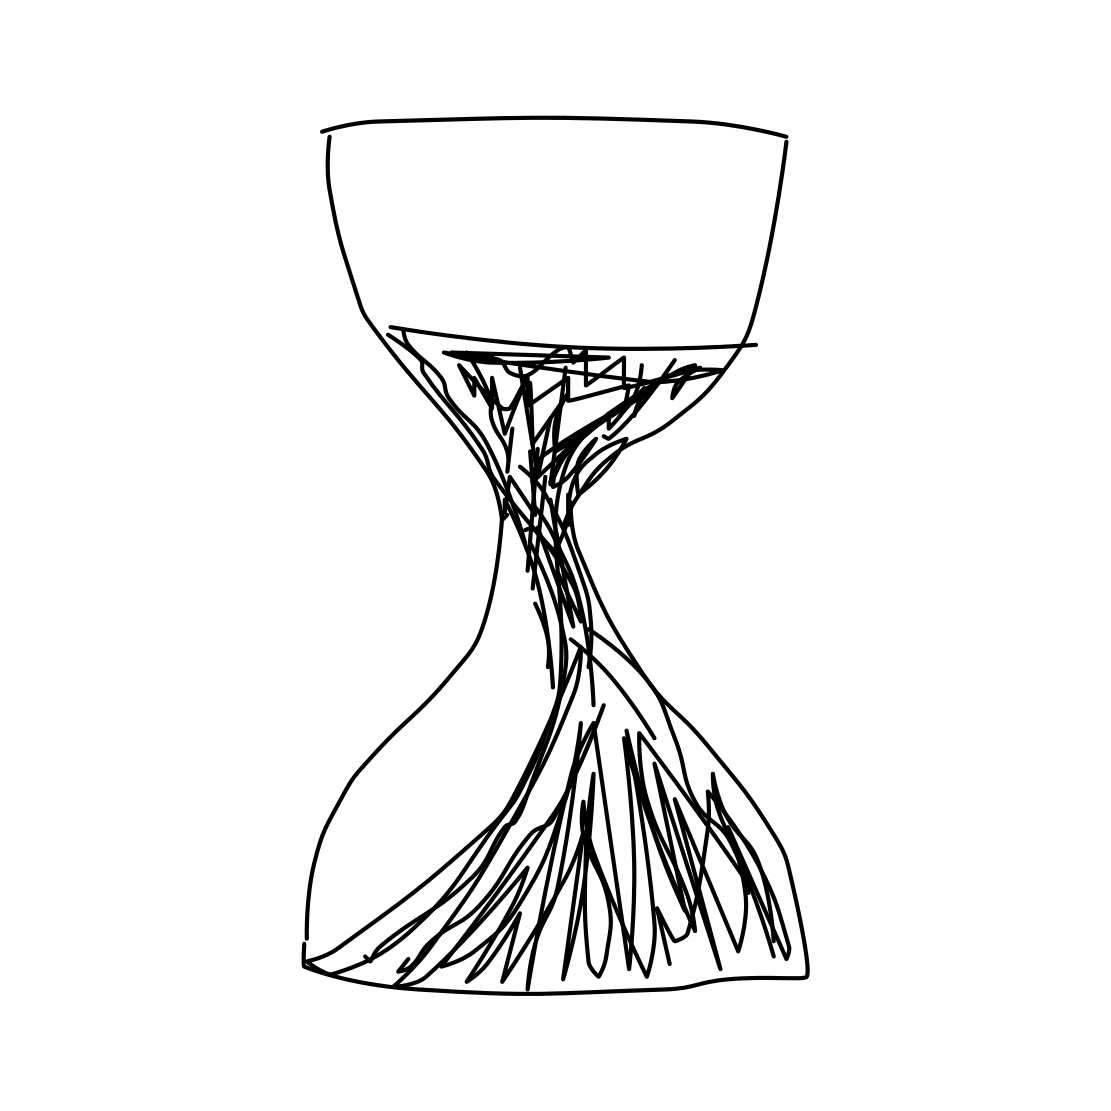How could this hourglass be interpreted in a philosophical context? Philosophically, the hourglass might symbolize the relentless march of time and its unyielding nature, serving as a reminder of human mortality. It can also represent the cyclical nature of life, with each grain of sand marking a moment that contributes to the broader scope of one's existence. 